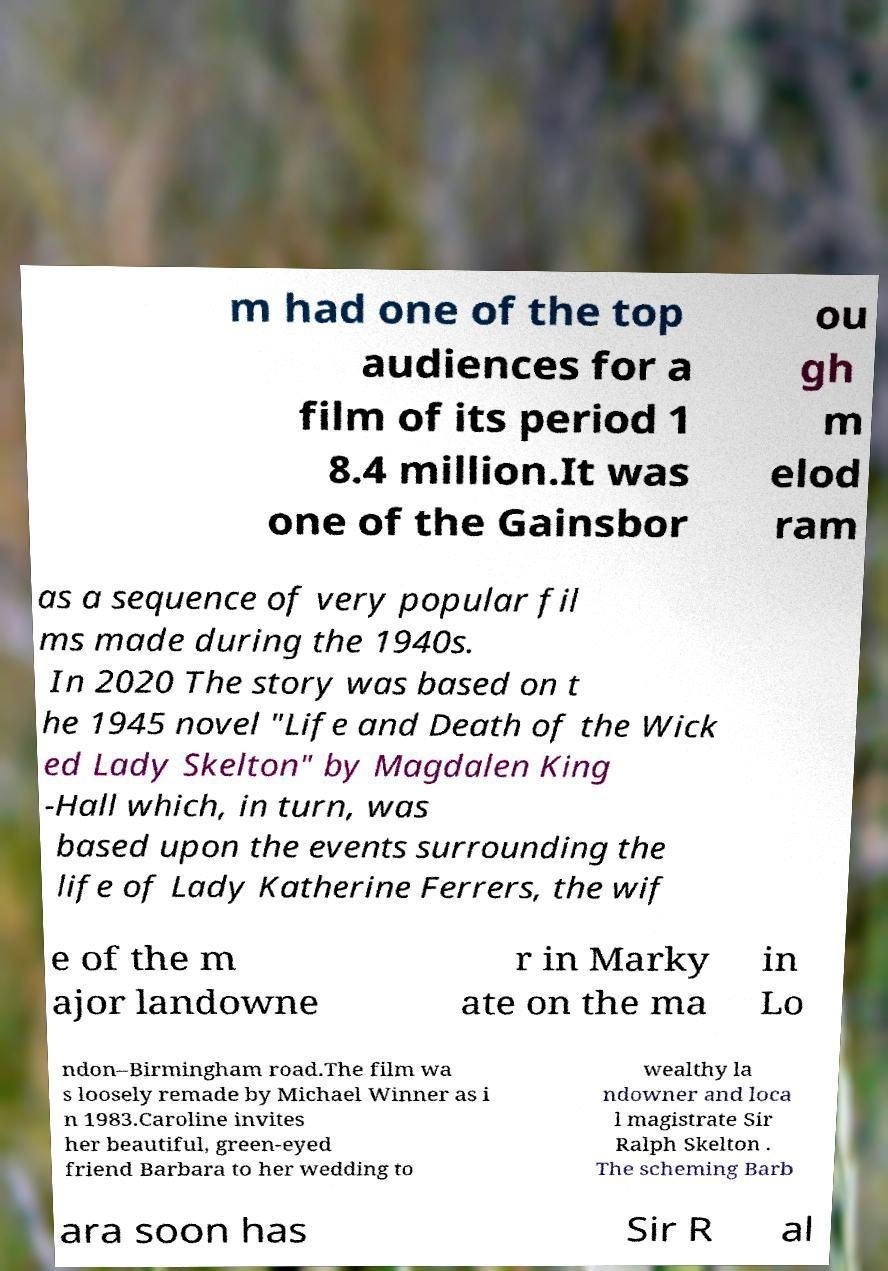Can you accurately transcribe the text from the provided image for me? m had one of the top audiences for a film of its period 1 8.4 million.It was one of the Gainsbor ou gh m elod ram as a sequence of very popular fil ms made during the 1940s. In 2020 The story was based on t he 1945 novel "Life and Death of the Wick ed Lady Skelton" by Magdalen King -Hall which, in turn, was based upon the events surrounding the life of Lady Katherine Ferrers, the wif e of the m ajor landowne r in Marky ate on the ma in Lo ndon–Birmingham road.The film wa s loosely remade by Michael Winner as i n 1983.Caroline invites her beautiful, green-eyed friend Barbara to her wedding to wealthy la ndowner and loca l magistrate Sir Ralph Skelton . The scheming Barb ara soon has Sir R al 